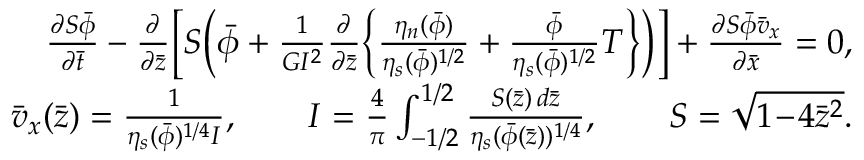Convert formula to latex. <formula><loc_0><loc_0><loc_500><loc_500>\begin{array} { r l r } & { \frac { \partial S \bar { \phi } } { \partial \bar { t } } - \frac { \partial } { \partial \bar { z } } \left [ S \left ( \bar { \phi } + \frac { 1 } { G I ^ { 2 } } \frac { \partial } { \partial \bar { z } } \left \{ \frac { \eta _ { n } ( \bar { \phi } ) } { \eta _ { s } ( \bar { \phi } ) ^ { 1 / 2 } } + \frac { \bar { \phi } } { \eta _ { s } ( \bar { \phi } ) ^ { 1 / 2 } } T \right \} \right ) \right ] + \frac { \partial S \bar { \phi } \bar { v } _ { x } } { \partial \bar { x } } = 0 , } \\ & { \bar { v } _ { x } ( \bar { z } ) = \frac { 1 } { \eta _ { s } ( \bar { \phi } ) ^ { 1 / 4 } I } , \quad I = \frac { 4 } { \pi } \int _ { - 1 / 2 } ^ { 1 / 2 } \frac { S ( \bar { z } ) \, d \bar { z } } { \eta _ { s } ( \bar { \phi } ( \bar { z } ) ) ^ { 1 / 4 } } , \quad S = \sqrt { 1 \, - \, 4 \bar { z } ^ { 2 } } . } \end{array}</formula> 